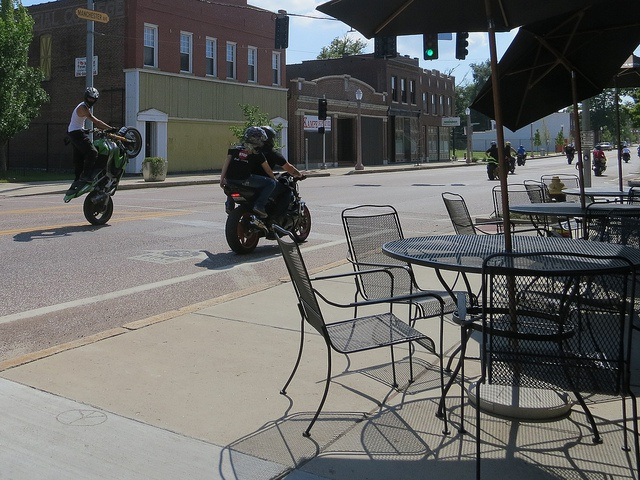Describe the objects in this image and their specific colors. I can see chair in teal, black, darkgray, and gray tones, umbrella in teal, black, and gray tones, dining table in teal, black, gray, and darkgray tones, umbrella in teal, black, gray, darkgray, and lightgray tones, and chair in teal, darkgray, black, gray, and lightgray tones in this image. 